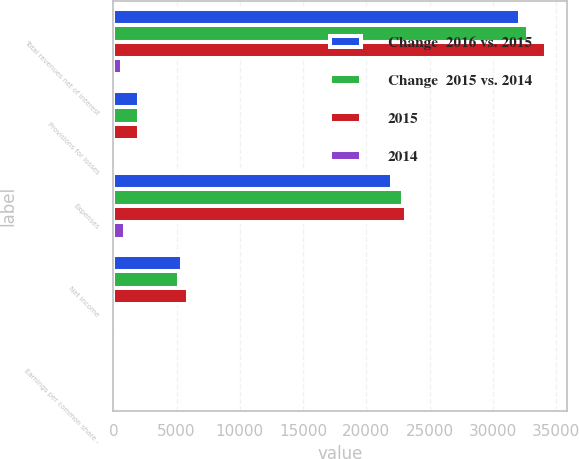Convert chart. <chart><loc_0><loc_0><loc_500><loc_500><stacked_bar_chart><ecel><fcel>Total revenues net of interest<fcel>Provisions for losses<fcel>Expenses<fcel>Net income<fcel>Earnings per common share -<nl><fcel>Change  2016 vs. 2015<fcel>32119<fcel>2026<fcel>21997<fcel>5408<fcel>5.65<nl><fcel>Change  2015 vs. 2014<fcel>32818<fcel>1988<fcel>22892<fcel>5163<fcel>5.05<nl><fcel>2015<fcel>34188<fcel>2044<fcel>23153<fcel>5885<fcel>5.56<nl><fcel>2014<fcel>699<fcel>38<fcel>895<fcel>245<fcel>0.6<nl></chart> 